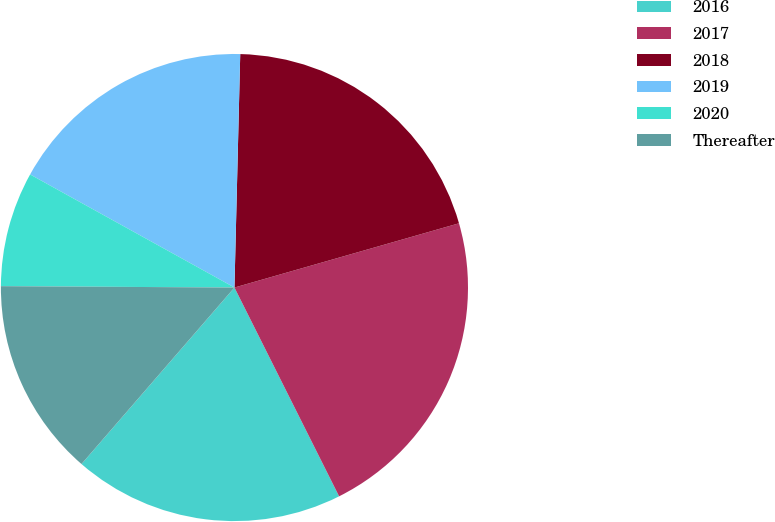Convert chart to OTSL. <chart><loc_0><loc_0><loc_500><loc_500><pie_chart><fcel>2016<fcel>2017<fcel>2018<fcel>2019<fcel>2020<fcel>Thereafter<nl><fcel>18.76%<fcel>22.04%<fcel>20.17%<fcel>17.35%<fcel>7.95%<fcel>13.73%<nl></chart> 